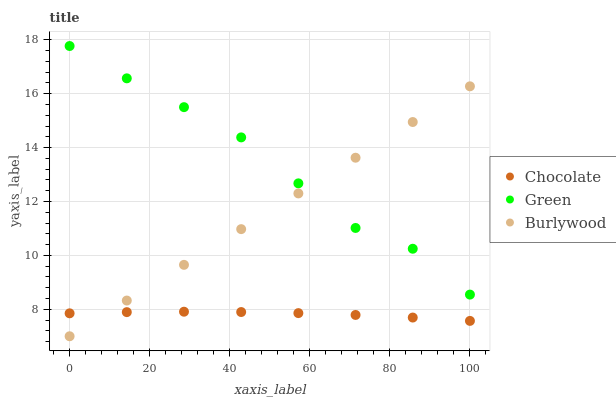Does Chocolate have the minimum area under the curve?
Answer yes or no. Yes. Does Green have the maximum area under the curve?
Answer yes or no. Yes. Does Green have the minimum area under the curve?
Answer yes or no. No. Does Chocolate have the maximum area under the curve?
Answer yes or no. No. Is Burlywood the smoothest?
Answer yes or no. Yes. Is Green the roughest?
Answer yes or no. Yes. Is Chocolate the smoothest?
Answer yes or no. No. Is Chocolate the roughest?
Answer yes or no. No. Does Burlywood have the lowest value?
Answer yes or no. Yes. Does Chocolate have the lowest value?
Answer yes or no. No. Does Green have the highest value?
Answer yes or no. Yes. Does Chocolate have the highest value?
Answer yes or no. No. Is Chocolate less than Green?
Answer yes or no. Yes. Is Green greater than Chocolate?
Answer yes or no. Yes. Does Burlywood intersect Green?
Answer yes or no. Yes. Is Burlywood less than Green?
Answer yes or no. No. Is Burlywood greater than Green?
Answer yes or no. No. Does Chocolate intersect Green?
Answer yes or no. No. 